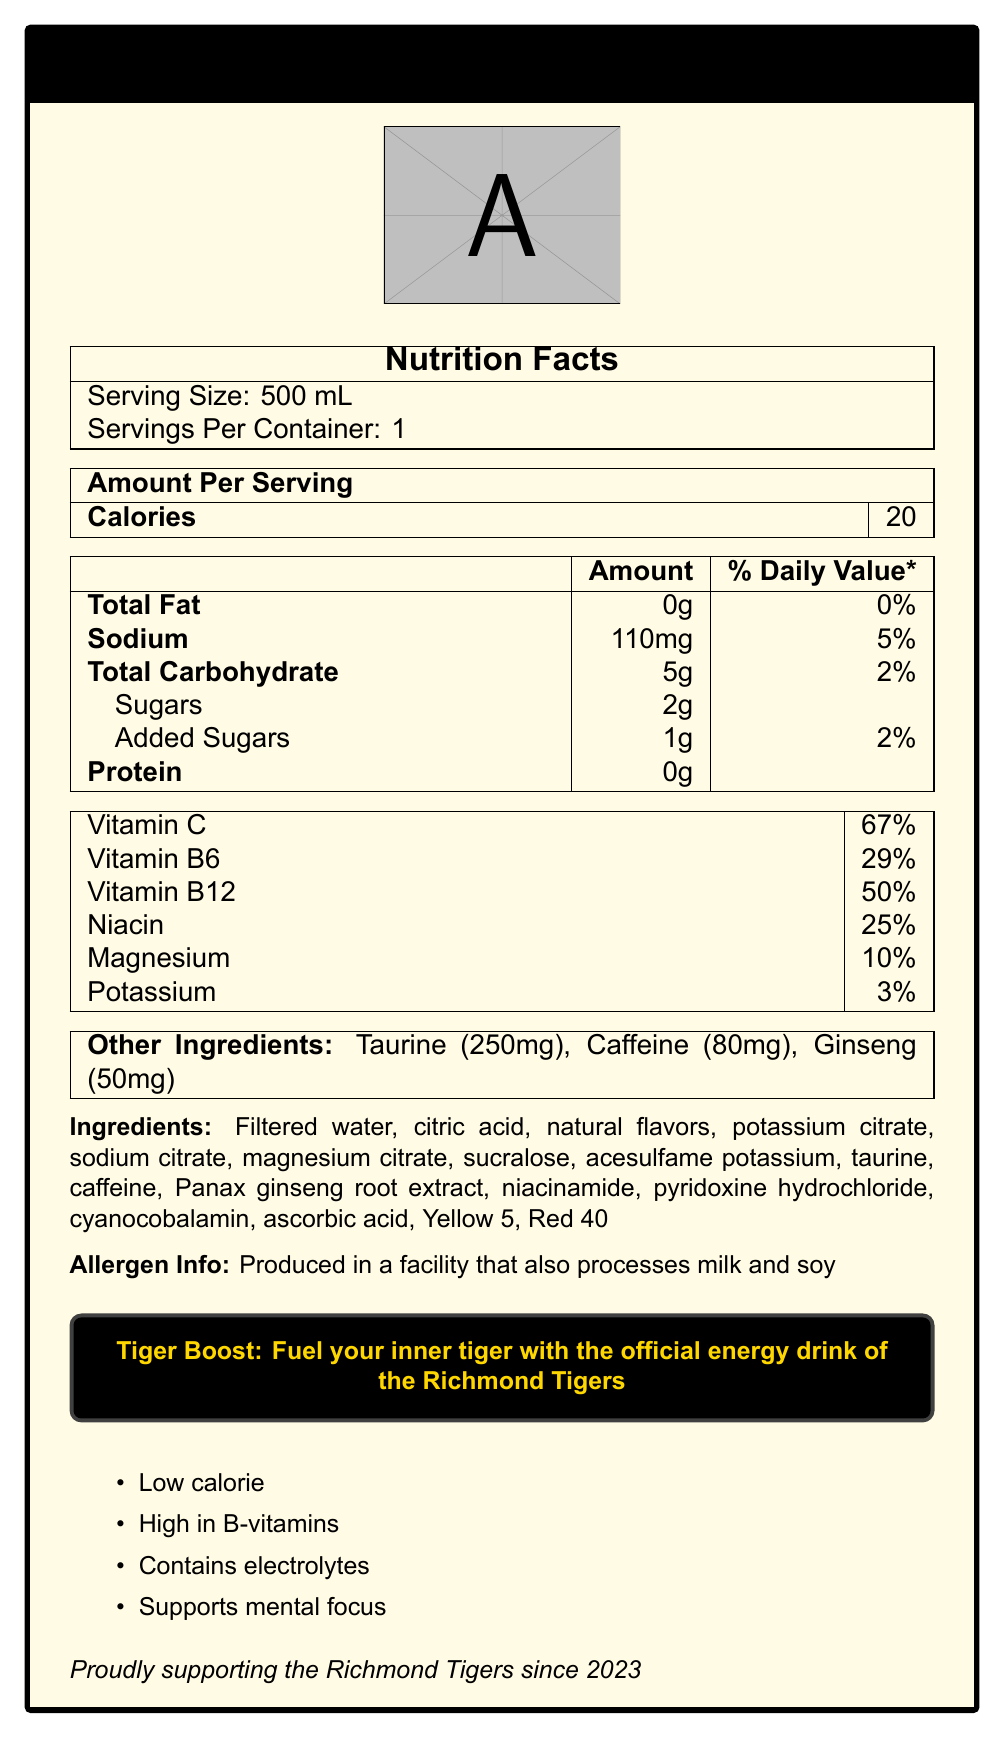What is the serving size for Tiger Boost? The serving size is explicitly mentioned as 500 mL in the Nutrition Facts section.
Answer: 500 mL How many calories are there per serving of Tiger Boost? The document specifies 20 calories per serving in the "Amount Per Serving" section.
Answer: 20 How much sodium does Tiger Boost contain? Sodium content is listed as 110mg in the nutrition facts details.
Answer: 110mg What percentage of the daily value does vitamin C in Tiger Boost contribute? Vitamin C contributes 67% of the daily value as per the nutrition facts section.
Answer: 67% What are the primary colors of the Tiger Boost sports drink packaging? The document mentions that the primary color scheme is Yellow and Black.
Answer: Yellow and Black What is the total carbohydrate content per serving of Tiger Boost? A. 2g B. 3g C. 4g D. 5g The total carbohydrate content is listed as 5g per serving under the "Total Carbohydrate" section.
Answer: D Which vitamin in Tiger Boost has the highest daily value percentage? A. Vitamin B6 B. Vitamin B12 C. Vitamin C D. Niacin Vitamin C has the highest daily value percentage at 67%.
Answer: C Is Tiger Boost a low-calorie drink? The document highlights "Low calorie" as a marketing claim, and the total calories per serving is only 20.
Answer: Yes Does Tiger Boost contain any protein? The nutrition facts clearly state that there is 0g of protein in the drink.
Answer: No Summarize the main idea of the document. The document describes the nutritional information, ingredients, marketing claims, and endorsement details for a sports drink named Tiger Boost. It highlights its low-calorie nature, high vitamin content, and affiliation with the Richmond Tigers.
Answer: Tiger Boost is a low-calorie, high-energy sports drink packed with B-vitamins, electrolytes, and other energy-boosting ingredients. It is specifically endorsed by the Richmond Tigers and features a yellow and black color scheme. The drink offers multiple health benefits such as mental focus support and essential vitamins and minerals. What is the manufacturing facility's allergen information? The allergen information is explicitly stated as "Produced in a facility that also processes milk and soy."
Answer: Produced in a facility that also processes milk and soy What is the amount of taurine in Tiger Boost? The document lists taurine content as 250mg in the "Other Ingredients" section.
Answer: 250mg Can you determine the exact flavor of Tiger Boost from the document? The document only mentions "natural flavors" and does not specify the exact flavor of Tiger Boost.
Answer: No Who does Tiger Boost support as an official energy drink? The document clearly states "Tiger Boost: Fuel your inner tiger with the official energy drink of the Richmond Tigers."
Answer: The Richmond Tigers What ingredient in Tiger Boost can help with mental focus? The marketing claims include "Supports mental focus," and caffeine is known for its benefits to mental alertness.
Answer: Caffeine What is the daily value percentage of niacin in Tiger Boost? According to the nutrition facts, niacin contributes 25% to the daily value.
Answer: 25% Does the packaging of Tiger Boost feature the Richmond Tigers' branding? The document mentions that Tiger Boost is endorsed and proudly supports the Richmond Tigers since 2023.
Answer: Yes Is Vitamin B12 content higher than the Vitamin B6 content in Tiger Boost? Vitamin B12 content is 50% of the daily value, which is higher than Vitamin B6 content at 29%.
Answer: Yes 